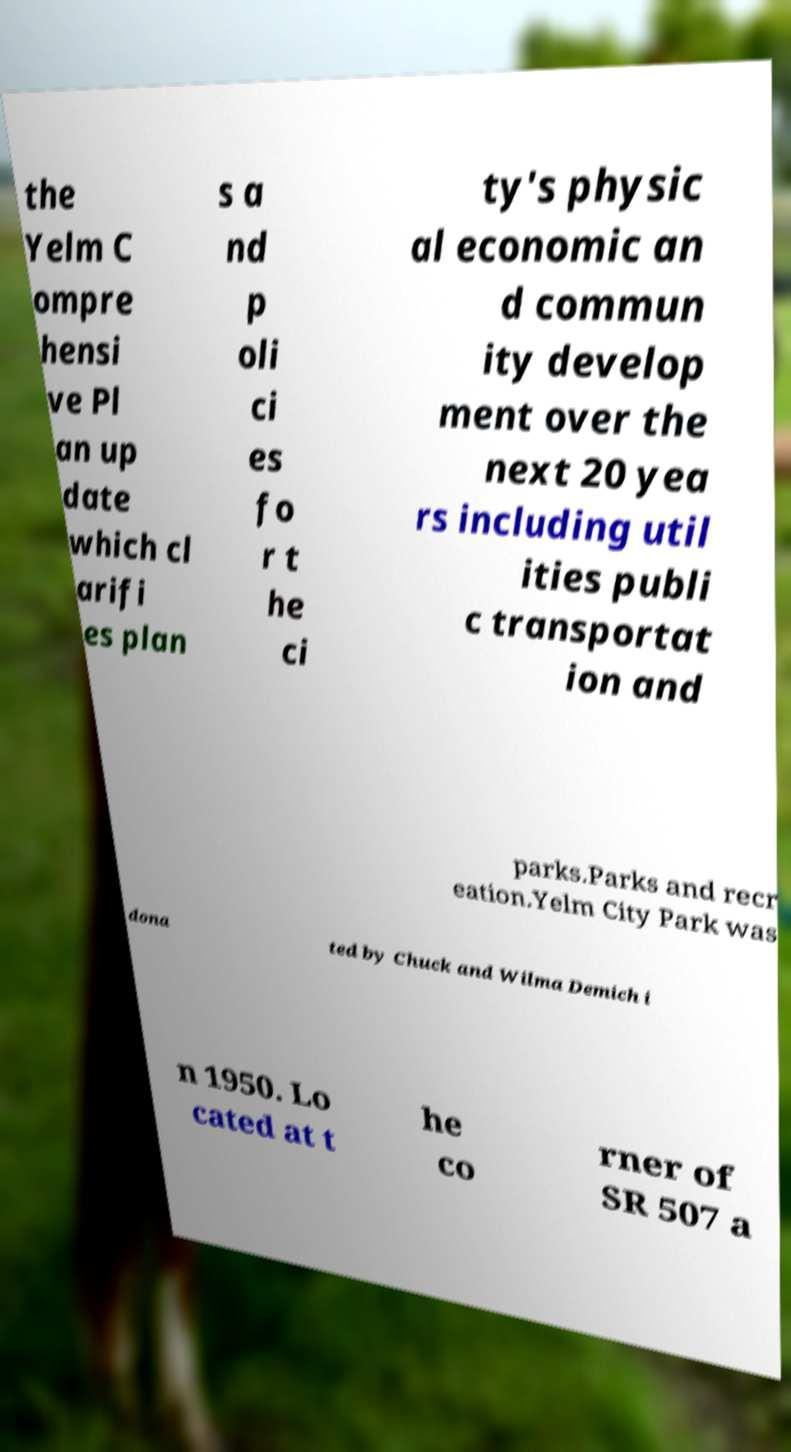Could you extract and type out the text from this image? the Yelm C ompre hensi ve Pl an up date which cl arifi es plan s a nd p oli ci es fo r t he ci ty's physic al economic an d commun ity develop ment over the next 20 yea rs including util ities publi c transportat ion and parks.Parks and recr eation.Yelm City Park was dona ted by Chuck and Wilma Demich i n 1950. Lo cated at t he co rner of SR 507 a 